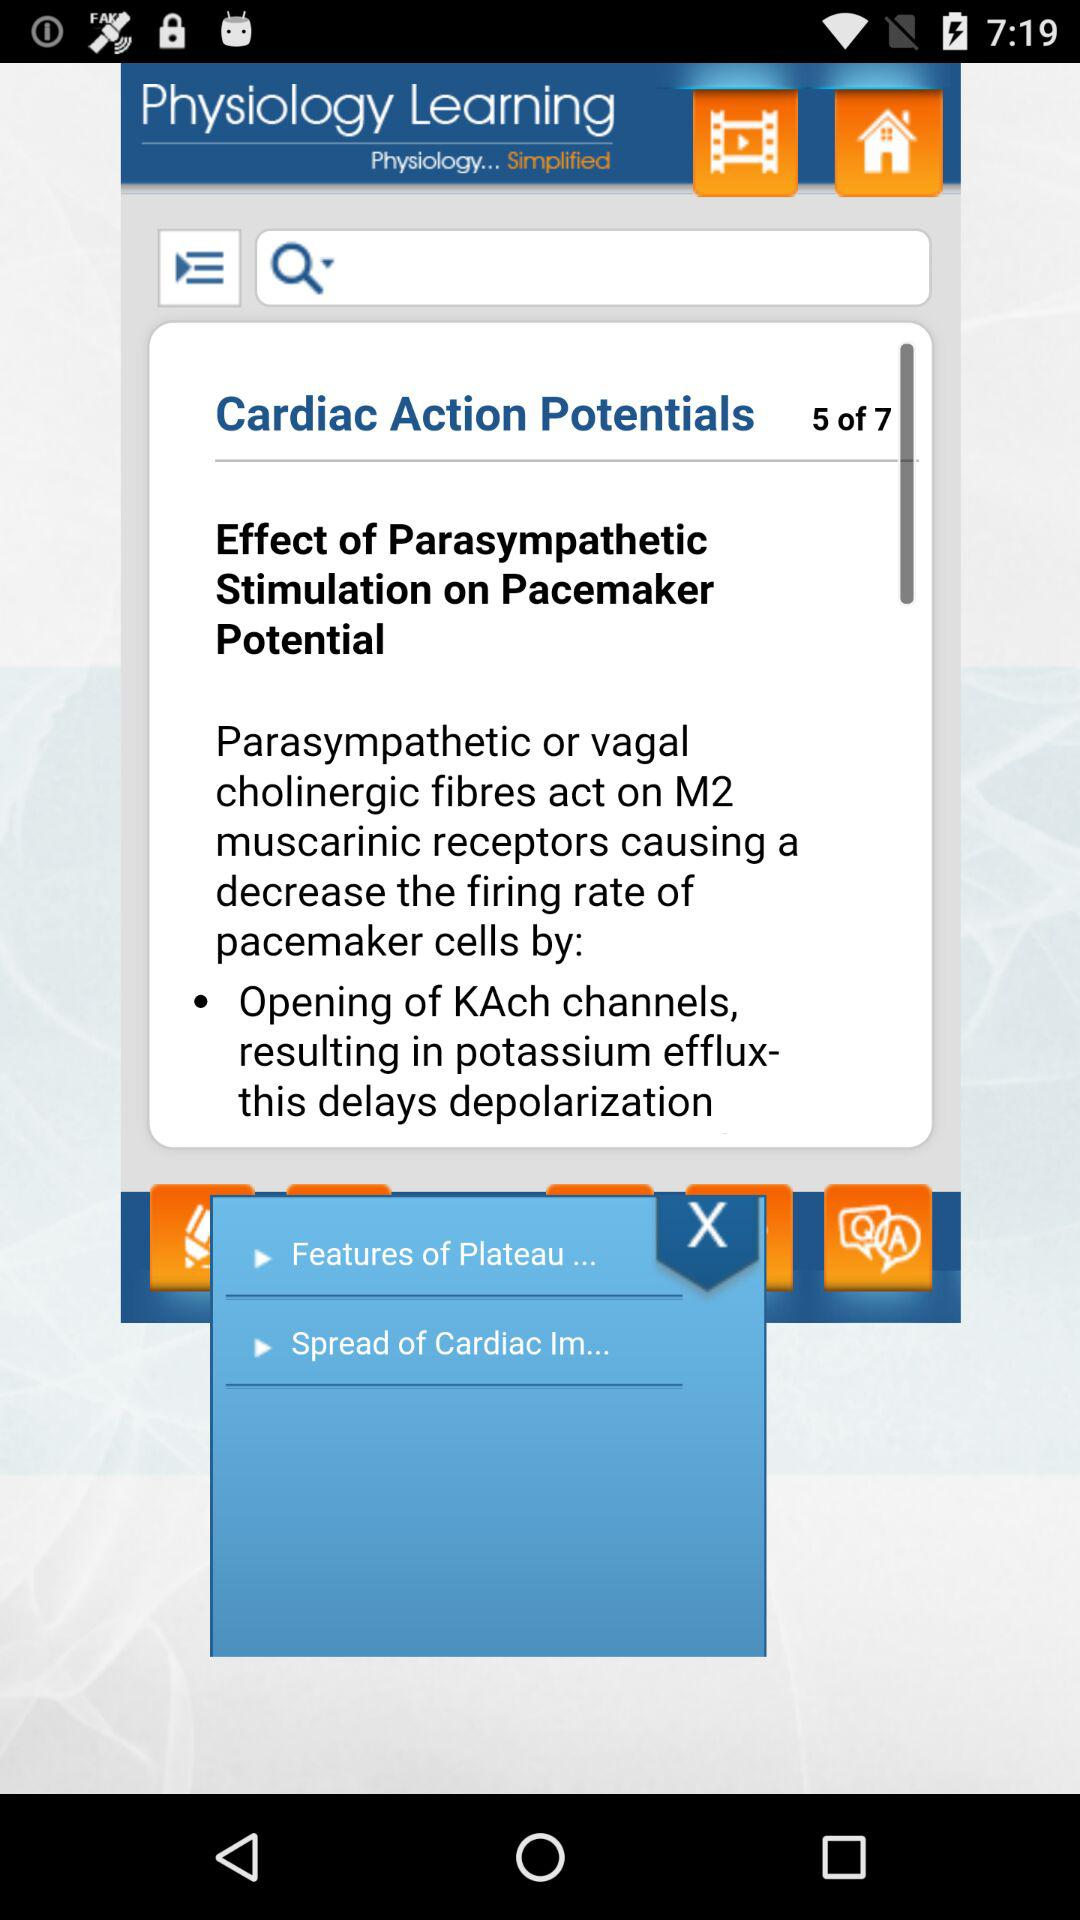Which page number of "Cardiac Action Potentials" am I on? You are on page number 5 of "Cardiac Action Potentials". 